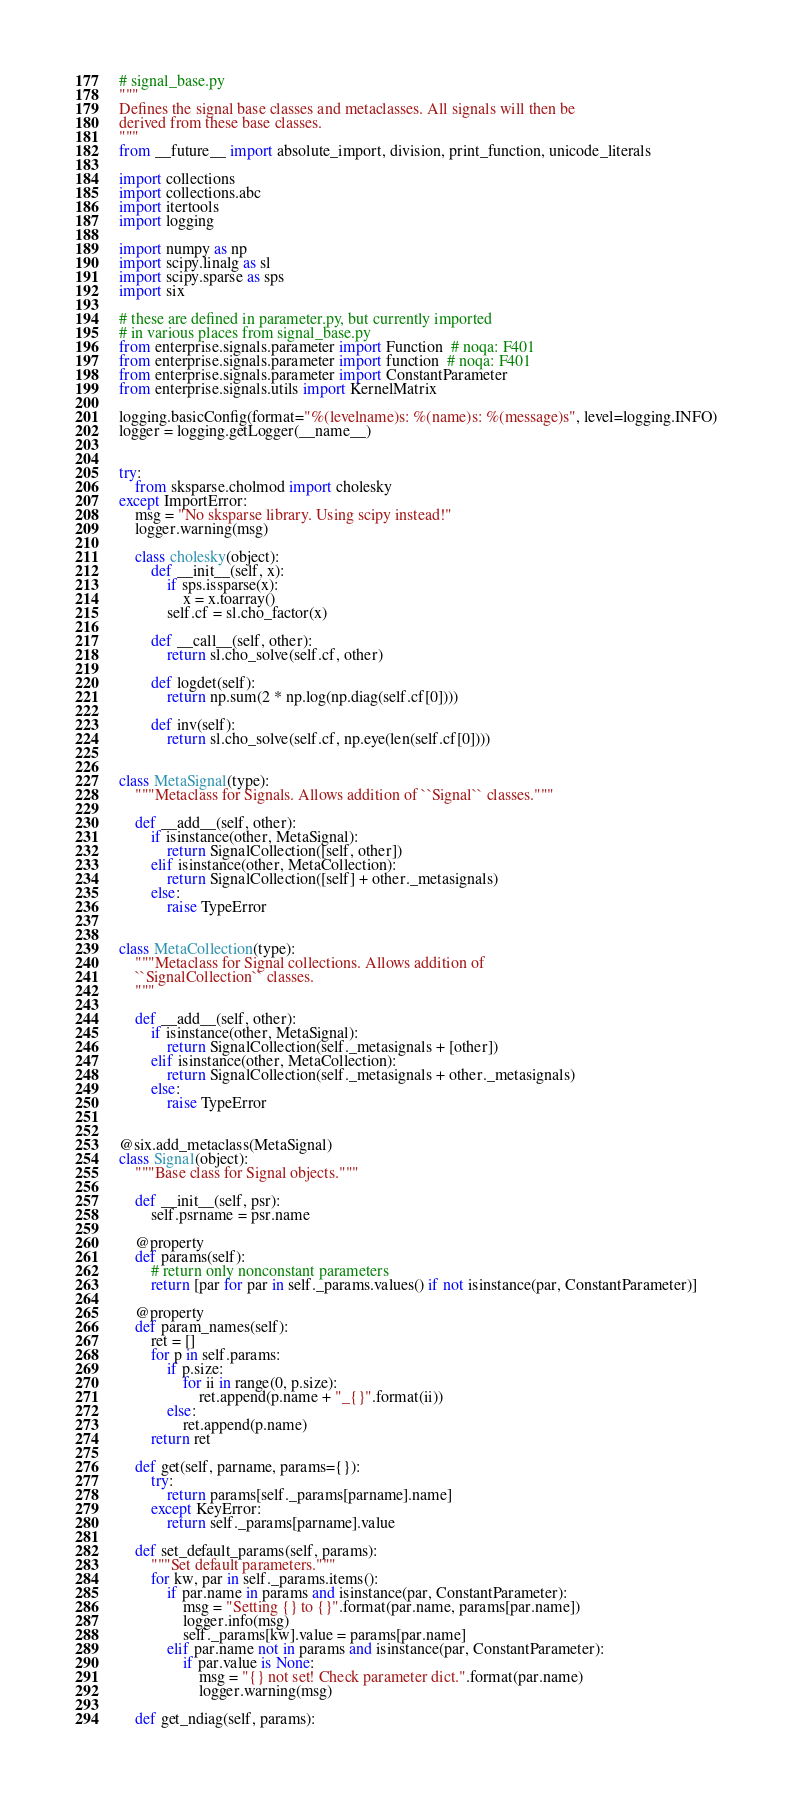Convert code to text. <code><loc_0><loc_0><loc_500><loc_500><_Python_># signal_base.py
"""
Defines the signal base classes and metaclasses. All signals will then be
derived from these base classes.
"""
from __future__ import absolute_import, division, print_function, unicode_literals

import collections
import collections.abc
import itertools
import logging

import numpy as np
import scipy.linalg as sl
import scipy.sparse as sps
import six

# these are defined in parameter.py, but currently imported
# in various places from signal_base.py
from enterprise.signals.parameter import Function  # noqa: F401
from enterprise.signals.parameter import function  # noqa: F401
from enterprise.signals.parameter import ConstantParameter
from enterprise.signals.utils import KernelMatrix

logging.basicConfig(format="%(levelname)s: %(name)s: %(message)s", level=logging.INFO)
logger = logging.getLogger(__name__)


try:
    from sksparse.cholmod import cholesky
except ImportError:
    msg = "No sksparse library. Using scipy instead!"
    logger.warning(msg)

    class cholesky(object):
        def __init__(self, x):
            if sps.issparse(x):
                x = x.toarray()
            self.cf = sl.cho_factor(x)

        def __call__(self, other):
            return sl.cho_solve(self.cf, other)

        def logdet(self):
            return np.sum(2 * np.log(np.diag(self.cf[0])))

        def inv(self):
            return sl.cho_solve(self.cf, np.eye(len(self.cf[0])))


class MetaSignal(type):
    """Metaclass for Signals. Allows addition of ``Signal`` classes."""

    def __add__(self, other):
        if isinstance(other, MetaSignal):
            return SignalCollection([self, other])
        elif isinstance(other, MetaCollection):
            return SignalCollection([self] + other._metasignals)
        else:
            raise TypeError


class MetaCollection(type):
    """Metaclass for Signal collections. Allows addition of
    ``SignalCollection`` classes.
    """

    def __add__(self, other):
        if isinstance(other, MetaSignal):
            return SignalCollection(self._metasignals + [other])
        elif isinstance(other, MetaCollection):
            return SignalCollection(self._metasignals + other._metasignals)
        else:
            raise TypeError


@six.add_metaclass(MetaSignal)
class Signal(object):
    """Base class for Signal objects."""

    def __init__(self, psr):
        self.psrname = psr.name

    @property
    def params(self):
        # return only nonconstant parameters
        return [par for par in self._params.values() if not isinstance(par, ConstantParameter)]

    @property
    def param_names(self):
        ret = []
        for p in self.params:
            if p.size:
                for ii in range(0, p.size):
                    ret.append(p.name + "_{}".format(ii))
            else:
                ret.append(p.name)
        return ret

    def get(self, parname, params={}):
        try:
            return params[self._params[parname].name]
        except KeyError:
            return self._params[parname].value

    def set_default_params(self, params):
        """Set default parameters."""
        for kw, par in self._params.items():
            if par.name in params and isinstance(par, ConstantParameter):
                msg = "Setting {} to {}".format(par.name, params[par.name])
                logger.info(msg)
                self._params[kw].value = params[par.name]
            elif par.name not in params and isinstance(par, ConstantParameter):
                if par.value is None:
                    msg = "{} not set! Check parameter dict.".format(par.name)
                    logger.warning(msg)

    def get_ndiag(self, params):</code> 